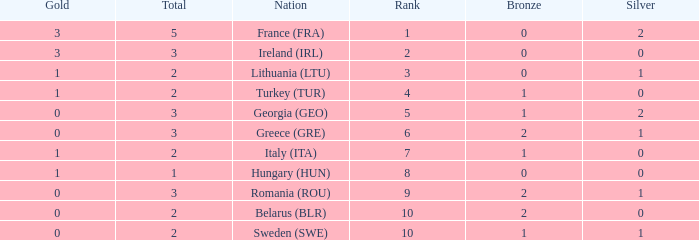What's the total number of bronze medals for Sweden (SWE) having less than 1 gold and silver? 0.0. 